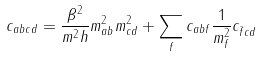Convert formula to latex. <formula><loc_0><loc_0><loc_500><loc_500>c _ { a b c d } = \frac { \beta ^ { 2 } } { m ^ { 2 } h } m _ { a b } ^ { 2 } m _ { c d } ^ { 2 } + \sum _ { f } c _ { a b f } \frac { 1 } { m _ { f } ^ { 2 } } c _ { \bar { f } c d }</formula> 